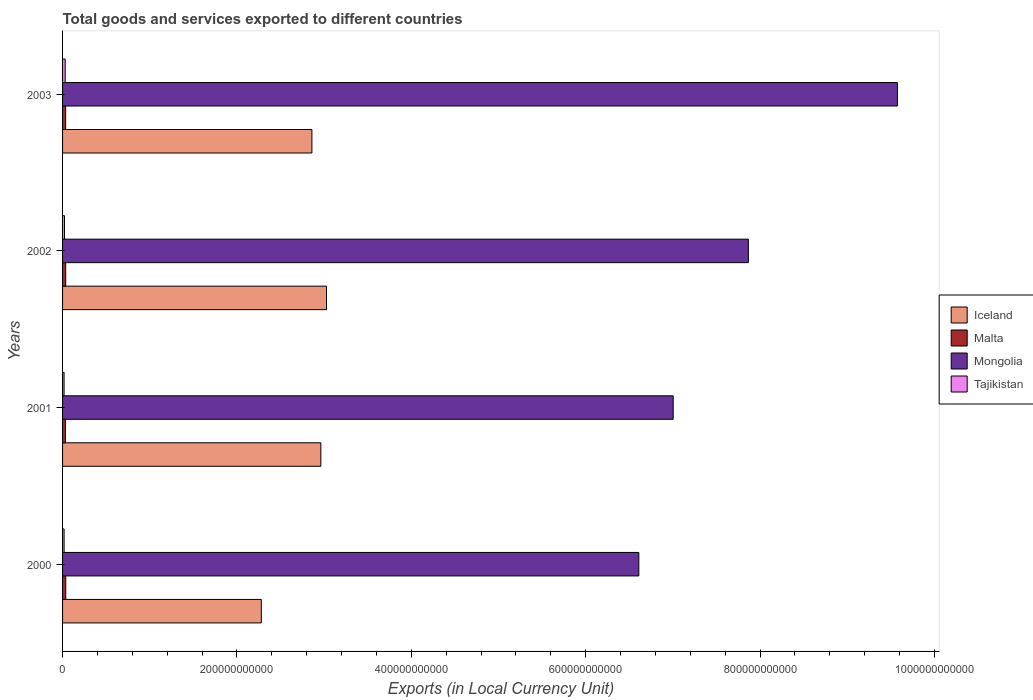Are the number of bars per tick equal to the number of legend labels?
Your response must be concise. Yes. How many bars are there on the 1st tick from the bottom?
Provide a short and direct response. 4. In how many cases, is the number of bars for a given year not equal to the number of legend labels?
Keep it short and to the point. 0. What is the Amount of goods and services exports in Tajikistan in 2001?
Provide a short and direct response. 1.74e+09. Across all years, what is the maximum Amount of goods and services exports in Tajikistan?
Provide a short and direct response. 3.02e+09. Across all years, what is the minimum Amount of goods and services exports in Tajikistan?
Provide a short and direct response. 1.74e+09. In which year was the Amount of goods and services exports in Malta maximum?
Your answer should be compact. 2000. What is the total Amount of goods and services exports in Mongolia in the graph?
Provide a succinct answer. 3.11e+12. What is the difference between the Amount of goods and services exports in Malta in 2000 and that in 2001?
Your answer should be very brief. 3.53e+08. What is the difference between the Amount of goods and services exports in Iceland in 2000 and the Amount of goods and services exports in Tajikistan in 2003?
Make the answer very short. 2.25e+11. What is the average Amount of goods and services exports in Iceland per year?
Offer a very short reply. 2.78e+11. In the year 2000, what is the difference between the Amount of goods and services exports in Mongolia and Amount of goods and services exports in Malta?
Give a very brief answer. 6.57e+11. What is the ratio of the Amount of goods and services exports in Mongolia in 2000 to that in 2003?
Provide a short and direct response. 0.69. Is the Amount of goods and services exports in Mongolia in 2000 less than that in 2001?
Your answer should be compact. Yes. Is the difference between the Amount of goods and services exports in Mongolia in 2001 and 2002 greater than the difference between the Amount of goods and services exports in Malta in 2001 and 2002?
Your answer should be compact. No. What is the difference between the highest and the second highest Amount of goods and services exports in Malta?
Provide a short and direct response. 5.06e+07. What is the difference between the highest and the lowest Amount of goods and services exports in Malta?
Keep it short and to the point. 3.53e+08. Is the sum of the Amount of goods and services exports in Tajikistan in 2000 and 2001 greater than the maximum Amount of goods and services exports in Iceland across all years?
Your response must be concise. No. What does the 2nd bar from the top in 2002 represents?
Your response must be concise. Mongolia. What does the 4th bar from the bottom in 2003 represents?
Keep it short and to the point. Tajikistan. Is it the case that in every year, the sum of the Amount of goods and services exports in Tajikistan and Amount of goods and services exports in Malta is greater than the Amount of goods and services exports in Mongolia?
Offer a terse response. No. Are all the bars in the graph horizontal?
Offer a very short reply. Yes. What is the difference between two consecutive major ticks on the X-axis?
Your answer should be very brief. 2.00e+11. Are the values on the major ticks of X-axis written in scientific E-notation?
Your answer should be very brief. No. Where does the legend appear in the graph?
Ensure brevity in your answer.  Center right. How many legend labels are there?
Provide a succinct answer. 4. How are the legend labels stacked?
Give a very brief answer. Vertical. What is the title of the graph?
Make the answer very short. Total goods and services exported to different countries. What is the label or title of the X-axis?
Give a very brief answer. Exports (in Local Currency Unit). What is the label or title of the Y-axis?
Make the answer very short. Years. What is the Exports (in Local Currency Unit) of Iceland in 2000?
Your answer should be very brief. 2.28e+11. What is the Exports (in Local Currency Unit) in Malta in 2000?
Provide a short and direct response. 3.66e+09. What is the Exports (in Local Currency Unit) of Mongolia in 2000?
Your answer should be compact. 6.61e+11. What is the Exports (in Local Currency Unit) in Tajikistan in 2000?
Provide a short and direct response. 1.76e+09. What is the Exports (in Local Currency Unit) of Iceland in 2001?
Provide a short and direct response. 2.96e+11. What is the Exports (in Local Currency Unit) of Malta in 2001?
Give a very brief answer. 3.30e+09. What is the Exports (in Local Currency Unit) in Mongolia in 2001?
Your response must be concise. 7.00e+11. What is the Exports (in Local Currency Unit) of Tajikistan in 2001?
Keep it short and to the point. 1.74e+09. What is the Exports (in Local Currency Unit) of Iceland in 2002?
Ensure brevity in your answer.  3.03e+11. What is the Exports (in Local Currency Unit) of Malta in 2002?
Ensure brevity in your answer.  3.61e+09. What is the Exports (in Local Currency Unit) in Mongolia in 2002?
Make the answer very short. 7.87e+11. What is the Exports (in Local Currency Unit) in Tajikistan in 2002?
Keep it short and to the point. 2.21e+09. What is the Exports (in Local Currency Unit) in Iceland in 2003?
Provide a short and direct response. 2.86e+11. What is the Exports (in Local Currency Unit) in Malta in 2003?
Your response must be concise. 3.55e+09. What is the Exports (in Local Currency Unit) of Mongolia in 2003?
Offer a terse response. 9.58e+11. What is the Exports (in Local Currency Unit) of Tajikistan in 2003?
Provide a short and direct response. 3.02e+09. Across all years, what is the maximum Exports (in Local Currency Unit) of Iceland?
Provide a succinct answer. 3.03e+11. Across all years, what is the maximum Exports (in Local Currency Unit) of Malta?
Give a very brief answer. 3.66e+09. Across all years, what is the maximum Exports (in Local Currency Unit) of Mongolia?
Offer a terse response. 9.58e+11. Across all years, what is the maximum Exports (in Local Currency Unit) of Tajikistan?
Your answer should be very brief. 3.02e+09. Across all years, what is the minimum Exports (in Local Currency Unit) of Iceland?
Offer a terse response. 2.28e+11. Across all years, what is the minimum Exports (in Local Currency Unit) of Malta?
Your response must be concise. 3.30e+09. Across all years, what is the minimum Exports (in Local Currency Unit) of Mongolia?
Your response must be concise. 6.61e+11. Across all years, what is the minimum Exports (in Local Currency Unit) in Tajikistan?
Offer a terse response. 1.74e+09. What is the total Exports (in Local Currency Unit) in Iceland in the graph?
Provide a short and direct response. 1.11e+12. What is the total Exports (in Local Currency Unit) in Malta in the graph?
Offer a terse response. 1.41e+1. What is the total Exports (in Local Currency Unit) of Mongolia in the graph?
Offer a terse response. 3.11e+12. What is the total Exports (in Local Currency Unit) of Tajikistan in the graph?
Offer a terse response. 8.73e+09. What is the difference between the Exports (in Local Currency Unit) of Iceland in 2000 and that in 2001?
Give a very brief answer. -6.83e+1. What is the difference between the Exports (in Local Currency Unit) in Malta in 2000 and that in 2001?
Offer a very short reply. 3.53e+08. What is the difference between the Exports (in Local Currency Unit) in Mongolia in 2000 and that in 2001?
Your response must be concise. -3.94e+1. What is the difference between the Exports (in Local Currency Unit) in Tajikistan in 2000 and that in 2001?
Offer a terse response. 2.15e+07. What is the difference between the Exports (in Local Currency Unit) of Iceland in 2000 and that in 2002?
Ensure brevity in your answer.  -7.48e+1. What is the difference between the Exports (in Local Currency Unit) in Malta in 2000 and that in 2002?
Keep it short and to the point. 5.06e+07. What is the difference between the Exports (in Local Currency Unit) of Mongolia in 2000 and that in 2002?
Give a very brief answer. -1.26e+11. What is the difference between the Exports (in Local Currency Unit) of Tajikistan in 2000 and that in 2002?
Your answer should be very brief. -4.45e+08. What is the difference between the Exports (in Local Currency Unit) in Iceland in 2000 and that in 2003?
Offer a terse response. -5.80e+1. What is the difference between the Exports (in Local Currency Unit) in Malta in 2000 and that in 2003?
Ensure brevity in your answer.  1.11e+08. What is the difference between the Exports (in Local Currency Unit) of Mongolia in 2000 and that in 2003?
Keep it short and to the point. -2.97e+11. What is the difference between the Exports (in Local Currency Unit) of Tajikistan in 2000 and that in 2003?
Offer a terse response. -1.25e+09. What is the difference between the Exports (in Local Currency Unit) of Iceland in 2001 and that in 2002?
Your answer should be very brief. -6.49e+09. What is the difference between the Exports (in Local Currency Unit) of Malta in 2001 and that in 2002?
Offer a terse response. -3.03e+08. What is the difference between the Exports (in Local Currency Unit) of Mongolia in 2001 and that in 2002?
Your response must be concise. -8.62e+1. What is the difference between the Exports (in Local Currency Unit) of Tajikistan in 2001 and that in 2002?
Offer a terse response. -4.66e+08. What is the difference between the Exports (in Local Currency Unit) in Iceland in 2001 and that in 2003?
Offer a very short reply. 1.03e+1. What is the difference between the Exports (in Local Currency Unit) in Malta in 2001 and that in 2003?
Make the answer very short. -2.42e+08. What is the difference between the Exports (in Local Currency Unit) of Mongolia in 2001 and that in 2003?
Make the answer very short. -2.57e+11. What is the difference between the Exports (in Local Currency Unit) of Tajikistan in 2001 and that in 2003?
Your answer should be very brief. -1.27e+09. What is the difference between the Exports (in Local Currency Unit) of Iceland in 2002 and that in 2003?
Your response must be concise. 1.67e+1. What is the difference between the Exports (in Local Currency Unit) of Malta in 2002 and that in 2003?
Offer a terse response. 6.06e+07. What is the difference between the Exports (in Local Currency Unit) of Mongolia in 2002 and that in 2003?
Keep it short and to the point. -1.71e+11. What is the difference between the Exports (in Local Currency Unit) in Tajikistan in 2002 and that in 2003?
Your answer should be very brief. -8.06e+08. What is the difference between the Exports (in Local Currency Unit) of Iceland in 2000 and the Exports (in Local Currency Unit) of Malta in 2001?
Give a very brief answer. 2.25e+11. What is the difference between the Exports (in Local Currency Unit) of Iceland in 2000 and the Exports (in Local Currency Unit) of Mongolia in 2001?
Make the answer very short. -4.72e+11. What is the difference between the Exports (in Local Currency Unit) in Iceland in 2000 and the Exports (in Local Currency Unit) in Tajikistan in 2001?
Your response must be concise. 2.26e+11. What is the difference between the Exports (in Local Currency Unit) of Malta in 2000 and the Exports (in Local Currency Unit) of Mongolia in 2001?
Make the answer very short. -6.97e+11. What is the difference between the Exports (in Local Currency Unit) of Malta in 2000 and the Exports (in Local Currency Unit) of Tajikistan in 2001?
Make the answer very short. 1.91e+09. What is the difference between the Exports (in Local Currency Unit) of Mongolia in 2000 and the Exports (in Local Currency Unit) of Tajikistan in 2001?
Give a very brief answer. 6.59e+11. What is the difference between the Exports (in Local Currency Unit) in Iceland in 2000 and the Exports (in Local Currency Unit) in Malta in 2002?
Provide a short and direct response. 2.24e+11. What is the difference between the Exports (in Local Currency Unit) in Iceland in 2000 and the Exports (in Local Currency Unit) in Mongolia in 2002?
Provide a short and direct response. -5.59e+11. What is the difference between the Exports (in Local Currency Unit) of Iceland in 2000 and the Exports (in Local Currency Unit) of Tajikistan in 2002?
Give a very brief answer. 2.26e+11. What is the difference between the Exports (in Local Currency Unit) of Malta in 2000 and the Exports (in Local Currency Unit) of Mongolia in 2002?
Your response must be concise. -7.83e+11. What is the difference between the Exports (in Local Currency Unit) of Malta in 2000 and the Exports (in Local Currency Unit) of Tajikistan in 2002?
Your answer should be compact. 1.45e+09. What is the difference between the Exports (in Local Currency Unit) of Mongolia in 2000 and the Exports (in Local Currency Unit) of Tajikistan in 2002?
Keep it short and to the point. 6.59e+11. What is the difference between the Exports (in Local Currency Unit) of Iceland in 2000 and the Exports (in Local Currency Unit) of Malta in 2003?
Keep it short and to the point. 2.24e+11. What is the difference between the Exports (in Local Currency Unit) of Iceland in 2000 and the Exports (in Local Currency Unit) of Mongolia in 2003?
Keep it short and to the point. -7.30e+11. What is the difference between the Exports (in Local Currency Unit) in Iceland in 2000 and the Exports (in Local Currency Unit) in Tajikistan in 2003?
Offer a terse response. 2.25e+11. What is the difference between the Exports (in Local Currency Unit) of Malta in 2000 and the Exports (in Local Currency Unit) of Mongolia in 2003?
Make the answer very short. -9.54e+11. What is the difference between the Exports (in Local Currency Unit) of Malta in 2000 and the Exports (in Local Currency Unit) of Tajikistan in 2003?
Make the answer very short. 6.42e+08. What is the difference between the Exports (in Local Currency Unit) in Mongolia in 2000 and the Exports (in Local Currency Unit) in Tajikistan in 2003?
Provide a succinct answer. 6.58e+11. What is the difference between the Exports (in Local Currency Unit) in Iceland in 2001 and the Exports (in Local Currency Unit) in Malta in 2002?
Your response must be concise. 2.93e+11. What is the difference between the Exports (in Local Currency Unit) of Iceland in 2001 and the Exports (in Local Currency Unit) of Mongolia in 2002?
Your answer should be compact. -4.90e+11. What is the difference between the Exports (in Local Currency Unit) in Iceland in 2001 and the Exports (in Local Currency Unit) in Tajikistan in 2002?
Your response must be concise. 2.94e+11. What is the difference between the Exports (in Local Currency Unit) in Malta in 2001 and the Exports (in Local Currency Unit) in Mongolia in 2002?
Your answer should be very brief. -7.83e+11. What is the difference between the Exports (in Local Currency Unit) in Malta in 2001 and the Exports (in Local Currency Unit) in Tajikistan in 2002?
Offer a terse response. 1.09e+09. What is the difference between the Exports (in Local Currency Unit) of Mongolia in 2001 and the Exports (in Local Currency Unit) of Tajikistan in 2002?
Offer a terse response. 6.98e+11. What is the difference between the Exports (in Local Currency Unit) of Iceland in 2001 and the Exports (in Local Currency Unit) of Malta in 2003?
Offer a very short reply. 2.93e+11. What is the difference between the Exports (in Local Currency Unit) of Iceland in 2001 and the Exports (in Local Currency Unit) of Mongolia in 2003?
Give a very brief answer. -6.61e+11. What is the difference between the Exports (in Local Currency Unit) in Iceland in 2001 and the Exports (in Local Currency Unit) in Tajikistan in 2003?
Give a very brief answer. 2.93e+11. What is the difference between the Exports (in Local Currency Unit) of Malta in 2001 and the Exports (in Local Currency Unit) of Mongolia in 2003?
Your answer should be compact. -9.54e+11. What is the difference between the Exports (in Local Currency Unit) in Malta in 2001 and the Exports (in Local Currency Unit) in Tajikistan in 2003?
Offer a very short reply. 2.89e+08. What is the difference between the Exports (in Local Currency Unit) of Mongolia in 2001 and the Exports (in Local Currency Unit) of Tajikistan in 2003?
Your response must be concise. 6.97e+11. What is the difference between the Exports (in Local Currency Unit) of Iceland in 2002 and the Exports (in Local Currency Unit) of Malta in 2003?
Provide a succinct answer. 2.99e+11. What is the difference between the Exports (in Local Currency Unit) in Iceland in 2002 and the Exports (in Local Currency Unit) in Mongolia in 2003?
Provide a succinct answer. -6.55e+11. What is the difference between the Exports (in Local Currency Unit) in Iceland in 2002 and the Exports (in Local Currency Unit) in Tajikistan in 2003?
Keep it short and to the point. 3.00e+11. What is the difference between the Exports (in Local Currency Unit) of Malta in 2002 and the Exports (in Local Currency Unit) of Mongolia in 2003?
Ensure brevity in your answer.  -9.54e+11. What is the difference between the Exports (in Local Currency Unit) of Malta in 2002 and the Exports (in Local Currency Unit) of Tajikistan in 2003?
Offer a very short reply. 5.92e+08. What is the difference between the Exports (in Local Currency Unit) in Mongolia in 2002 and the Exports (in Local Currency Unit) in Tajikistan in 2003?
Your answer should be compact. 7.84e+11. What is the average Exports (in Local Currency Unit) of Iceland per year?
Offer a terse response. 2.78e+11. What is the average Exports (in Local Currency Unit) in Malta per year?
Keep it short and to the point. 3.53e+09. What is the average Exports (in Local Currency Unit) in Mongolia per year?
Ensure brevity in your answer.  7.76e+11. What is the average Exports (in Local Currency Unit) in Tajikistan per year?
Your answer should be very brief. 2.18e+09. In the year 2000, what is the difference between the Exports (in Local Currency Unit) in Iceland and Exports (in Local Currency Unit) in Malta?
Offer a terse response. 2.24e+11. In the year 2000, what is the difference between the Exports (in Local Currency Unit) in Iceland and Exports (in Local Currency Unit) in Mongolia?
Give a very brief answer. -4.33e+11. In the year 2000, what is the difference between the Exports (in Local Currency Unit) of Iceland and Exports (in Local Currency Unit) of Tajikistan?
Offer a terse response. 2.26e+11. In the year 2000, what is the difference between the Exports (in Local Currency Unit) of Malta and Exports (in Local Currency Unit) of Mongolia?
Make the answer very short. -6.57e+11. In the year 2000, what is the difference between the Exports (in Local Currency Unit) in Malta and Exports (in Local Currency Unit) in Tajikistan?
Provide a succinct answer. 1.89e+09. In the year 2000, what is the difference between the Exports (in Local Currency Unit) in Mongolia and Exports (in Local Currency Unit) in Tajikistan?
Keep it short and to the point. 6.59e+11. In the year 2001, what is the difference between the Exports (in Local Currency Unit) of Iceland and Exports (in Local Currency Unit) of Malta?
Offer a terse response. 2.93e+11. In the year 2001, what is the difference between the Exports (in Local Currency Unit) in Iceland and Exports (in Local Currency Unit) in Mongolia?
Make the answer very short. -4.04e+11. In the year 2001, what is the difference between the Exports (in Local Currency Unit) of Iceland and Exports (in Local Currency Unit) of Tajikistan?
Offer a terse response. 2.94e+11. In the year 2001, what is the difference between the Exports (in Local Currency Unit) in Malta and Exports (in Local Currency Unit) in Mongolia?
Give a very brief answer. -6.97e+11. In the year 2001, what is the difference between the Exports (in Local Currency Unit) of Malta and Exports (in Local Currency Unit) of Tajikistan?
Provide a succinct answer. 1.56e+09. In the year 2001, what is the difference between the Exports (in Local Currency Unit) of Mongolia and Exports (in Local Currency Unit) of Tajikistan?
Offer a very short reply. 6.99e+11. In the year 2002, what is the difference between the Exports (in Local Currency Unit) in Iceland and Exports (in Local Currency Unit) in Malta?
Your answer should be very brief. 2.99e+11. In the year 2002, what is the difference between the Exports (in Local Currency Unit) of Iceland and Exports (in Local Currency Unit) of Mongolia?
Provide a short and direct response. -4.84e+11. In the year 2002, what is the difference between the Exports (in Local Currency Unit) in Iceland and Exports (in Local Currency Unit) in Tajikistan?
Your answer should be compact. 3.01e+11. In the year 2002, what is the difference between the Exports (in Local Currency Unit) of Malta and Exports (in Local Currency Unit) of Mongolia?
Make the answer very short. -7.83e+11. In the year 2002, what is the difference between the Exports (in Local Currency Unit) of Malta and Exports (in Local Currency Unit) of Tajikistan?
Your answer should be very brief. 1.40e+09. In the year 2002, what is the difference between the Exports (in Local Currency Unit) in Mongolia and Exports (in Local Currency Unit) in Tajikistan?
Keep it short and to the point. 7.84e+11. In the year 2003, what is the difference between the Exports (in Local Currency Unit) of Iceland and Exports (in Local Currency Unit) of Malta?
Your answer should be very brief. 2.82e+11. In the year 2003, what is the difference between the Exports (in Local Currency Unit) of Iceland and Exports (in Local Currency Unit) of Mongolia?
Your answer should be compact. -6.72e+11. In the year 2003, what is the difference between the Exports (in Local Currency Unit) of Iceland and Exports (in Local Currency Unit) of Tajikistan?
Give a very brief answer. 2.83e+11. In the year 2003, what is the difference between the Exports (in Local Currency Unit) in Malta and Exports (in Local Currency Unit) in Mongolia?
Your answer should be compact. -9.54e+11. In the year 2003, what is the difference between the Exports (in Local Currency Unit) in Malta and Exports (in Local Currency Unit) in Tajikistan?
Provide a succinct answer. 5.31e+08. In the year 2003, what is the difference between the Exports (in Local Currency Unit) in Mongolia and Exports (in Local Currency Unit) in Tajikistan?
Your response must be concise. 9.55e+11. What is the ratio of the Exports (in Local Currency Unit) in Iceland in 2000 to that in 2001?
Make the answer very short. 0.77. What is the ratio of the Exports (in Local Currency Unit) of Malta in 2000 to that in 2001?
Your answer should be compact. 1.11. What is the ratio of the Exports (in Local Currency Unit) of Mongolia in 2000 to that in 2001?
Provide a short and direct response. 0.94. What is the ratio of the Exports (in Local Currency Unit) of Tajikistan in 2000 to that in 2001?
Offer a very short reply. 1.01. What is the ratio of the Exports (in Local Currency Unit) in Iceland in 2000 to that in 2002?
Give a very brief answer. 0.75. What is the ratio of the Exports (in Local Currency Unit) in Malta in 2000 to that in 2002?
Keep it short and to the point. 1.01. What is the ratio of the Exports (in Local Currency Unit) in Mongolia in 2000 to that in 2002?
Keep it short and to the point. 0.84. What is the ratio of the Exports (in Local Currency Unit) in Tajikistan in 2000 to that in 2002?
Give a very brief answer. 0.8. What is the ratio of the Exports (in Local Currency Unit) of Iceland in 2000 to that in 2003?
Keep it short and to the point. 0.8. What is the ratio of the Exports (in Local Currency Unit) in Malta in 2000 to that in 2003?
Your response must be concise. 1.03. What is the ratio of the Exports (in Local Currency Unit) of Mongolia in 2000 to that in 2003?
Your response must be concise. 0.69. What is the ratio of the Exports (in Local Currency Unit) of Tajikistan in 2000 to that in 2003?
Make the answer very short. 0.59. What is the ratio of the Exports (in Local Currency Unit) in Iceland in 2001 to that in 2002?
Make the answer very short. 0.98. What is the ratio of the Exports (in Local Currency Unit) in Malta in 2001 to that in 2002?
Your answer should be compact. 0.92. What is the ratio of the Exports (in Local Currency Unit) of Mongolia in 2001 to that in 2002?
Offer a terse response. 0.89. What is the ratio of the Exports (in Local Currency Unit) of Tajikistan in 2001 to that in 2002?
Your answer should be compact. 0.79. What is the ratio of the Exports (in Local Currency Unit) of Iceland in 2001 to that in 2003?
Make the answer very short. 1.04. What is the ratio of the Exports (in Local Currency Unit) in Malta in 2001 to that in 2003?
Ensure brevity in your answer.  0.93. What is the ratio of the Exports (in Local Currency Unit) in Mongolia in 2001 to that in 2003?
Your response must be concise. 0.73. What is the ratio of the Exports (in Local Currency Unit) of Tajikistan in 2001 to that in 2003?
Offer a terse response. 0.58. What is the ratio of the Exports (in Local Currency Unit) in Iceland in 2002 to that in 2003?
Offer a very short reply. 1.06. What is the ratio of the Exports (in Local Currency Unit) of Malta in 2002 to that in 2003?
Offer a terse response. 1.02. What is the ratio of the Exports (in Local Currency Unit) in Mongolia in 2002 to that in 2003?
Provide a short and direct response. 0.82. What is the ratio of the Exports (in Local Currency Unit) in Tajikistan in 2002 to that in 2003?
Ensure brevity in your answer.  0.73. What is the difference between the highest and the second highest Exports (in Local Currency Unit) of Iceland?
Make the answer very short. 6.49e+09. What is the difference between the highest and the second highest Exports (in Local Currency Unit) in Malta?
Offer a terse response. 5.06e+07. What is the difference between the highest and the second highest Exports (in Local Currency Unit) of Mongolia?
Make the answer very short. 1.71e+11. What is the difference between the highest and the second highest Exports (in Local Currency Unit) in Tajikistan?
Ensure brevity in your answer.  8.06e+08. What is the difference between the highest and the lowest Exports (in Local Currency Unit) of Iceland?
Provide a succinct answer. 7.48e+1. What is the difference between the highest and the lowest Exports (in Local Currency Unit) of Malta?
Offer a terse response. 3.53e+08. What is the difference between the highest and the lowest Exports (in Local Currency Unit) in Mongolia?
Offer a very short reply. 2.97e+11. What is the difference between the highest and the lowest Exports (in Local Currency Unit) in Tajikistan?
Provide a short and direct response. 1.27e+09. 